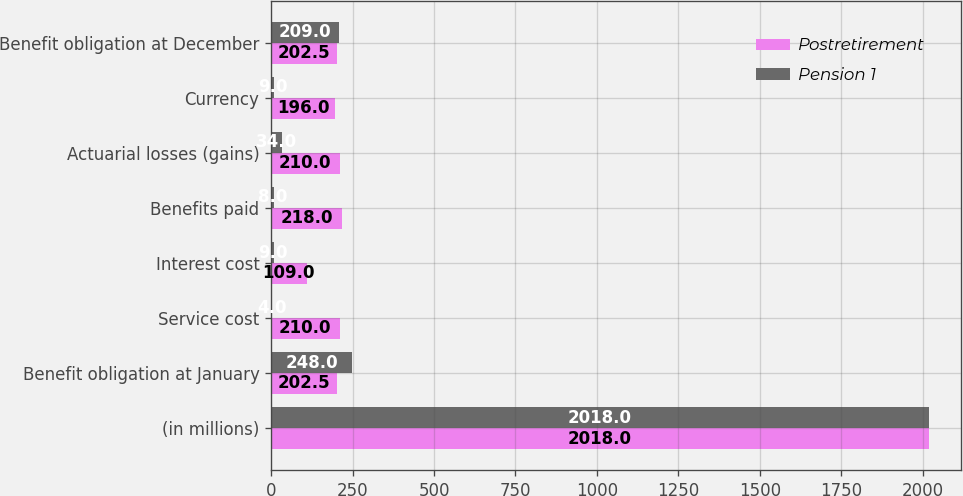Convert chart. <chart><loc_0><loc_0><loc_500><loc_500><stacked_bar_chart><ecel><fcel>(in millions)<fcel>Benefit obligation at January<fcel>Service cost<fcel>Interest cost<fcel>Benefits paid<fcel>Actuarial losses (gains)<fcel>Currency<fcel>Benefit obligation at December<nl><fcel>Postretirement<fcel>2018<fcel>202.5<fcel>210<fcel>109<fcel>218<fcel>210<fcel>196<fcel>202.5<nl><fcel>Pension 1<fcel>2018<fcel>248<fcel>4<fcel>9<fcel>8<fcel>34<fcel>9<fcel>209<nl></chart> 